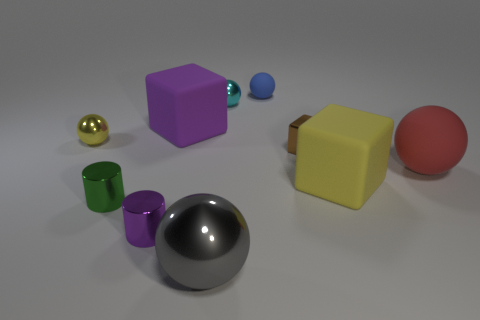What can you infer about the lighting in this scene? The lighting in the scene seems to be soft and diffused, coming from above as indicated by the reflections and shadows under the objects. There are no harsh shadows, suggesting the light source is quite large or there may be multiple sources. 